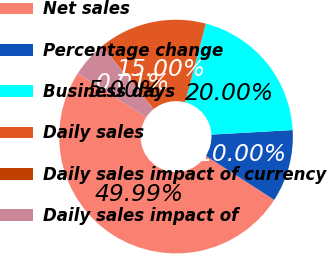<chart> <loc_0><loc_0><loc_500><loc_500><pie_chart><fcel>Net sales<fcel>Percentage change<fcel>Business days<fcel>Daily sales<fcel>Daily sales impact of currency<fcel>Daily sales impact of<nl><fcel>49.99%<fcel>10.0%<fcel>20.0%<fcel>15.0%<fcel>0.01%<fcel>5.0%<nl></chart> 